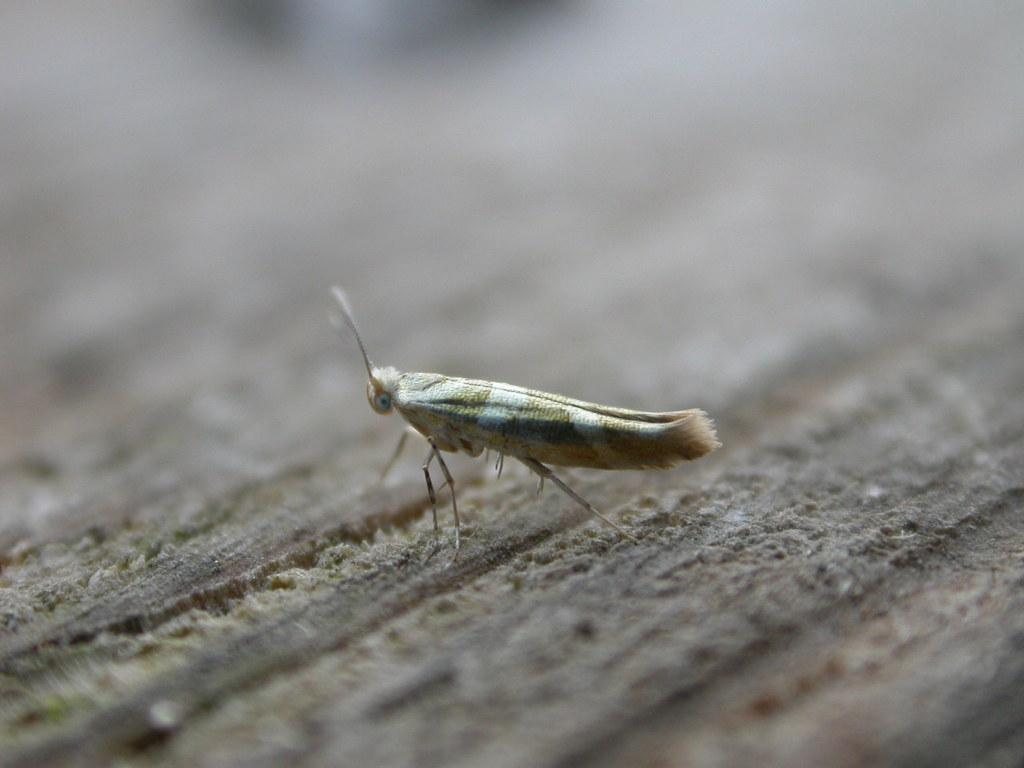What type of creature is present in the image? There is an insect in the image. Where is the insect located in the image? The insect is on an object. Reasoning: Let's think step by step by step in order to produce the conversation. We start by identifying the main subject in the image, which is the insect. Then, we expand the conversation to include the location of the insect, which is on an object. Each question is designed to elicit a specific detail about the image that is known from the provided facts. Absurd Question/Answer: What type of stitch is the owl using to sew the insect in the image? There is no owl or stitching activity present in the image; it features an insect on an object. What type of stitch is the owl using to sew the insect in the image? There is no owl or stitching activity present in the image; it features an insect on an object. 